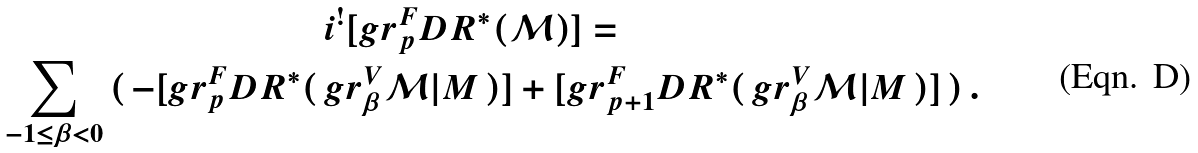<formula> <loc_0><loc_0><loc_500><loc_500>& i ^ { ! } [ g r ^ { F } _ { p } D R ^ { * } ( { \mathcal { M } } ) ] = \\ \sum _ { - 1 \leq \beta < 0 } \, ( \, - [ g r ^ { F } _ { p } D R ^ { * } ( \, & g r ^ { V } _ { \beta } { \mathcal { M } } | M \, ) ] + [ g r ^ { F } _ { p + 1 } D R ^ { * } ( \, g r ^ { V } _ { \beta } { \mathcal { M } } | M \, ) ] \, ) \, .</formula> 